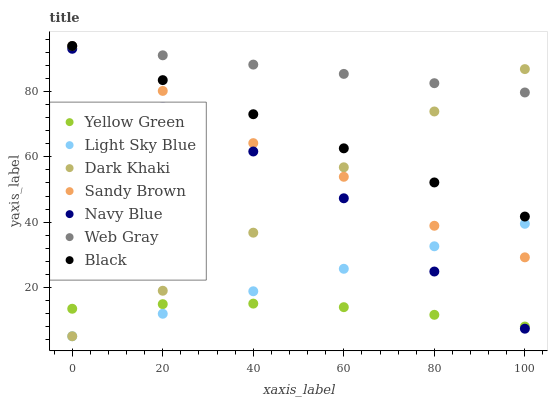Does Yellow Green have the minimum area under the curve?
Answer yes or no. Yes. Does Web Gray have the maximum area under the curve?
Answer yes or no. Yes. Does Navy Blue have the minimum area under the curve?
Answer yes or no. No. Does Navy Blue have the maximum area under the curve?
Answer yes or no. No. Is Black the smoothest?
Answer yes or no. Yes. Is Sandy Brown the roughest?
Answer yes or no. Yes. Is Yellow Green the smoothest?
Answer yes or no. No. Is Yellow Green the roughest?
Answer yes or no. No. Does Dark Khaki have the lowest value?
Answer yes or no. Yes. Does Yellow Green have the lowest value?
Answer yes or no. No. Does Sandy Brown have the highest value?
Answer yes or no. Yes. Does Navy Blue have the highest value?
Answer yes or no. No. Is Navy Blue less than Sandy Brown?
Answer yes or no. Yes. Is Web Gray greater than Navy Blue?
Answer yes or no. Yes. Does Black intersect Dark Khaki?
Answer yes or no. Yes. Is Black less than Dark Khaki?
Answer yes or no. No. Is Black greater than Dark Khaki?
Answer yes or no. No. Does Navy Blue intersect Sandy Brown?
Answer yes or no. No. 